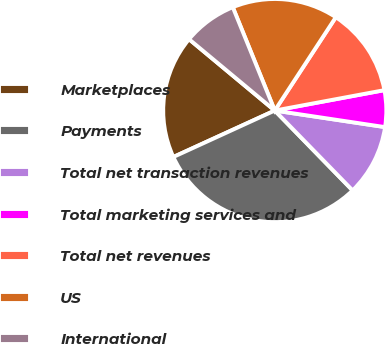<chart> <loc_0><loc_0><loc_500><loc_500><pie_chart><fcel>Marketplaces<fcel>Payments<fcel>Total net transaction revenues<fcel>Total marketing services and<fcel>Total net revenues<fcel>US<fcel>International<nl><fcel>17.88%<fcel>30.46%<fcel>10.33%<fcel>5.3%<fcel>12.85%<fcel>15.36%<fcel>7.81%<nl></chart> 